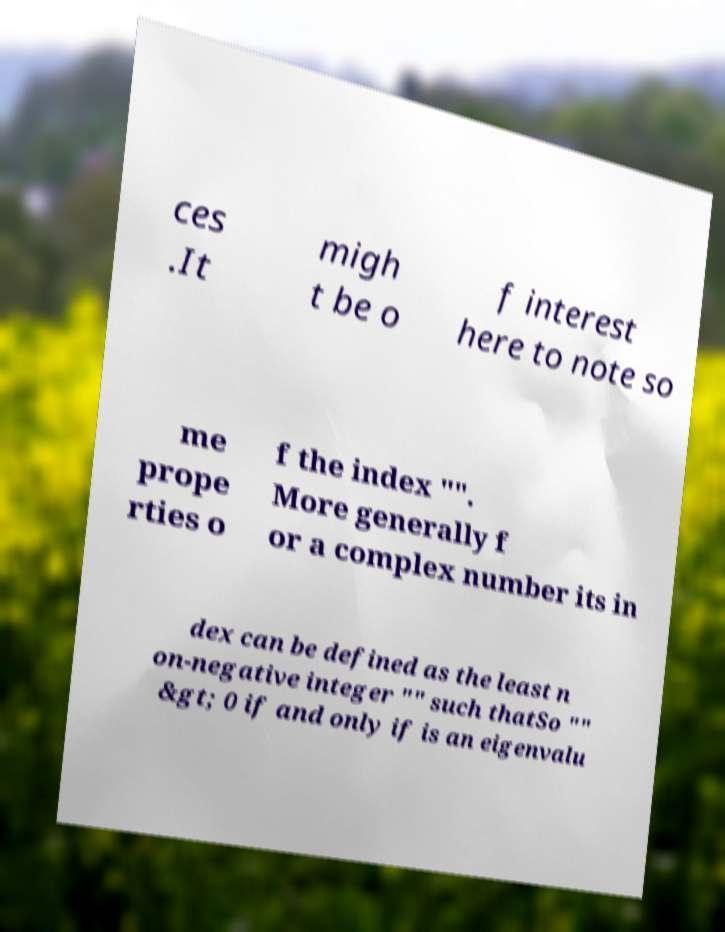What messages or text are displayed in this image? I need them in a readable, typed format. ces .It migh t be o f interest here to note so me prope rties o f the index "". More generally f or a complex number its in dex can be defined as the least n on-negative integer "" such thatSo "" &gt; 0 if and only if is an eigenvalu 